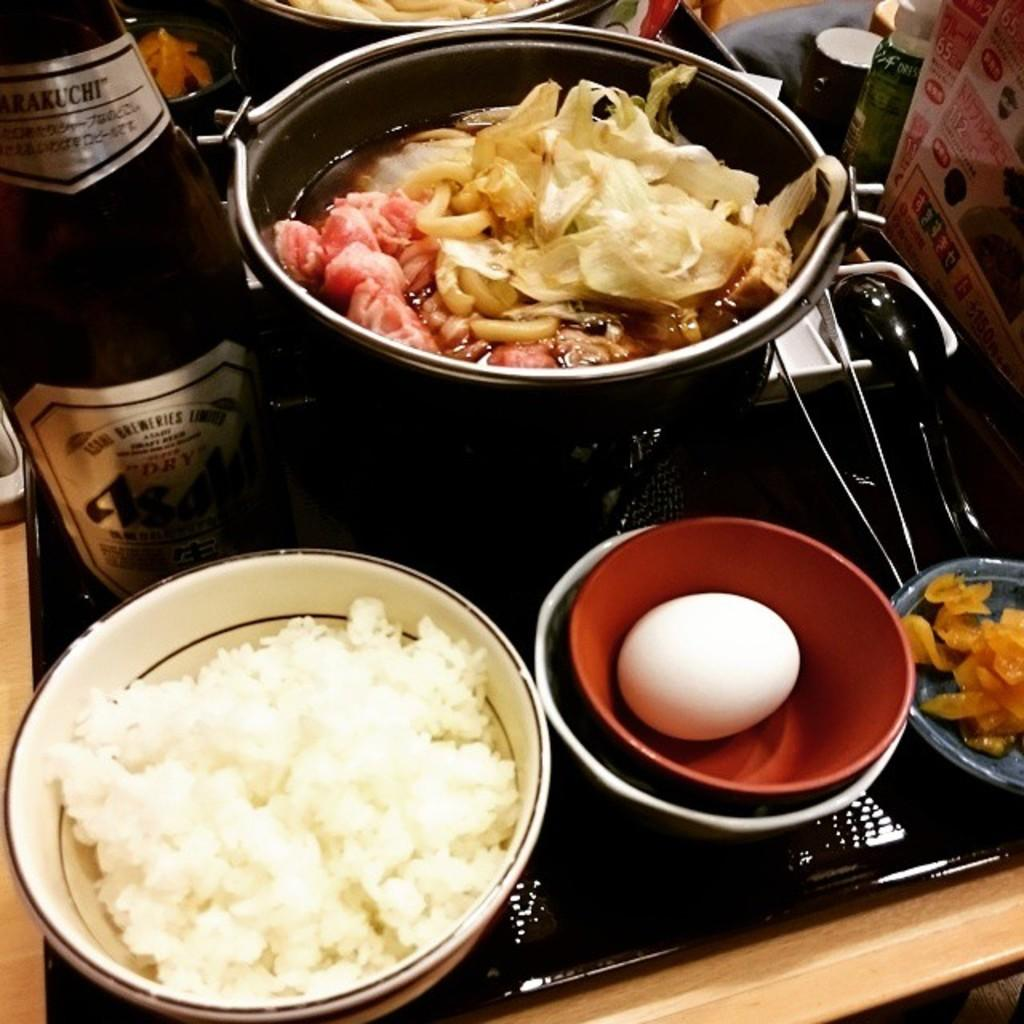Provide a one-sentence caption for the provided image. The number 65 is visible on a poster near where an asian meal is being cooked. 